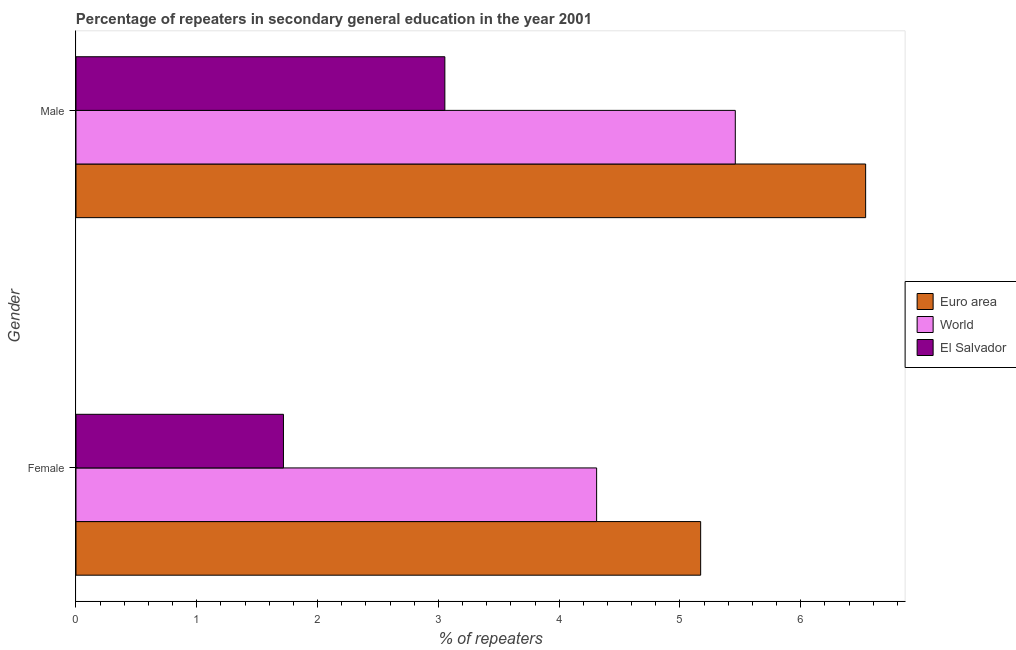How many different coloured bars are there?
Your response must be concise. 3. Are the number of bars on each tick of the Y-axis equal?
Ensure brevity in your answer.  Yes. How many bars are there on the 2nd tick from the top?
Offer a very short reply. 3. How many bars are there on the 2nd tick from the bottom?
Your response must be concise. 3. What is the percentage of male repeaters in El Salvador?
Provide a short and direct response. 3.05. Across all countries, what is the maximum percentage of male repeaters?
Make the answer very short. 6.54. Across all countries, what is the minimum percentage of male repeaters?
Ensure brevity in your answer.  3.05. In which country was the percentage of male repeaters minimum?
Your response must be concise. El Salvador. What is the total percentage of female repeaters in the graph?
Keep it short and to the point. 11.2. What is the difference between the percentage of male repeaters in El Salvador and that in Euro area?
Make the answer very short. -3.48. What is the difference between the percentage of female repeaters in El Salvador and the percentage of male repeaters in World?
Ensure brevity in your answer.  -3.74. What is the average percentage of female repeaters per country?
Offer a very short reply. 3.73. What is the difference between the percentage of female repeaters and percentage of male repeaters in World?
Your response must be concise. -1.15. What is the ratio of the percentage of female repeaters in El Salvador to that in Euro area?
Keep it short and to the point. 0.33. Is the percentage of female repeaters in El Salvador less than that in World?
Provide a succinct answer. Yes. What does the 1st bar from the top in Male represents?
Your answer should be compact. El Salvador. How many bars are there?
Offer a very short reply. 6. Does the graph contain any zero values?
Your response must be concise. No. Where does the legend appear in the graph?
Offer a terse response. Center right. What is the title of the graph?
Your answer should be very brief. Percentage of repeaters in secondary general education in the year 2001. Does "Latin America(developing only)" appear as one of the legend labels in the graph?
Ensure brevity in your answer.  No. What is the label or title of the X-axis?
Offer a terse response. % of repeaters. What is the % of repeaters of Euro area in Female?
Ensure brevity in your answer.  5.17. What is the % of repeaters in World in Female?
Provide a succinct answer. 4.31. What is the % of repeaters of El Salvador in Female?
Your answer should be very brief. 1.72. What is the % of repeaters in Euro area in Male?
Keep it short and to the point. 6.54. What is the % of repeaters of World in Male?
Provide a succinct answer. 5.46. What is the % of repeaters of El Salvador in Male?
Your answer should be compact. 3.05. Across all Gender, what is the maximum % of repeaters of Euro area?
Provide a short and direct response. 6.54. Across all Gender, what is the maximum % of repeaters in World?
Your answer should be very brief. 5.46. Across all Gender, what is the maximum % of repeaters of El Salvador?
Your answer should be compact. 3.05. Across all Gender, what is the minimum % of repeaters in Euro area?
Give a very brief answer. 5.17. Across all Gender, what is the minimum % of repeaters in World?
Your answer should be compact. 4.31. Across all Gender, what is the minimum % of repeaters of El Salvador?
Your answer should be very brief. 1.72. What is the total % of repeaters in Euro area in the graph?
Your response must be concise. 11.71. What is the total % of repeaters in World in the graph?
Your answer should be very brief. 9.77. What is the total % of repeaters of El Salvador in the graph?
Make the answer very short. 4.77. What is the difference between the % of repeaters in Euro area in Female and that in Male?
Keep it short and to the point. -1.37. What is the difference between the % of repeaters of World in Female and that in Male?
Offer a very short reply. -1.15. What is the difference between the % of repeaters in El Salvador in Female and that in Male?
Provide a short and direct response. -1.34. What is the difference between the % of repeaters in Euro area in Female and the % of repeaters in World in Male?
Your response must be concise. -0.29. What is the difference between the % of repeaters of Euro area in Female and the % of repeaters of El Salvador in Male?
Your answer should be compact. 2.12. What is the difference between the % of repeaters in World in Female and the % of repeaters in El Salvador in Male?
Provide a succinct answer. 1.26. What is the average % of repeaters of Euro area per Gender?
Give a very brief answer. 5.85. What is the average % of repeaters in World per Gender?
Give a very brief answer. 4.88. What is the average % of repeaters of El Salvador per Gender?
Give a very brief answer. 2.39. What is the difference between the % of repeaters of Euro area and % of repeaters of World in Female?
Provide a short and direct response. 0.86. What is the difference between the % of repeaters of Euro area and % of repeaters of El Salvador in Female?
Your answer should be very brief. 3.45. What is the difference between the % of repeaters in World and % of repeaters in El Salvador in Female?
Offer a terse response. 2.59. What is the difference between the % of repeaters of Euro area and % of repeaters of World in Male?
Make the answer very short. 1.08. What is the difference between the % of repeaters of Euro area and % of repeaters of El Salvador in Male?
Keep it short and to the point. 3.48. What is the difference between the % of repeaters of World and % of repeaters of El Salvador in Male?
Offer a very short reply. 2.4. What is the ratio of the % of repeaters in Euro area in Female to that in Male?
Provide a short and direct response. 0.79. What is the ratio of the % of repeaters of World in Female to that in Male?
Ensure brevity in your answer.  0.79. What is the ratio of the % of repeaters of El Salvador in Female to that in Male?
Keep it short and to the point. 0.56. What is the difference between the highest and the second highest % of repeaters in Euro area?
Your response must be concise. 1.37. What is the difference between the highest and the second highest % of repeaters in World?
Your answer should be compact. 1.15. What is the difference between the highest and the second highest % of repeaters in El Salvador?
Provide a succinct answer. 1.34. What is the difference between the highest and the lowest % of repeaters in Euro area?
Make the answer very short. 1.37. What is the difference between the highest and the lowest % of repeaters in World?
Make the answer very short. 1.15. What is the difference between the highest and the lowest % of repeaters in El Salvador?
Ensure brevity in your answer.  1.34. 